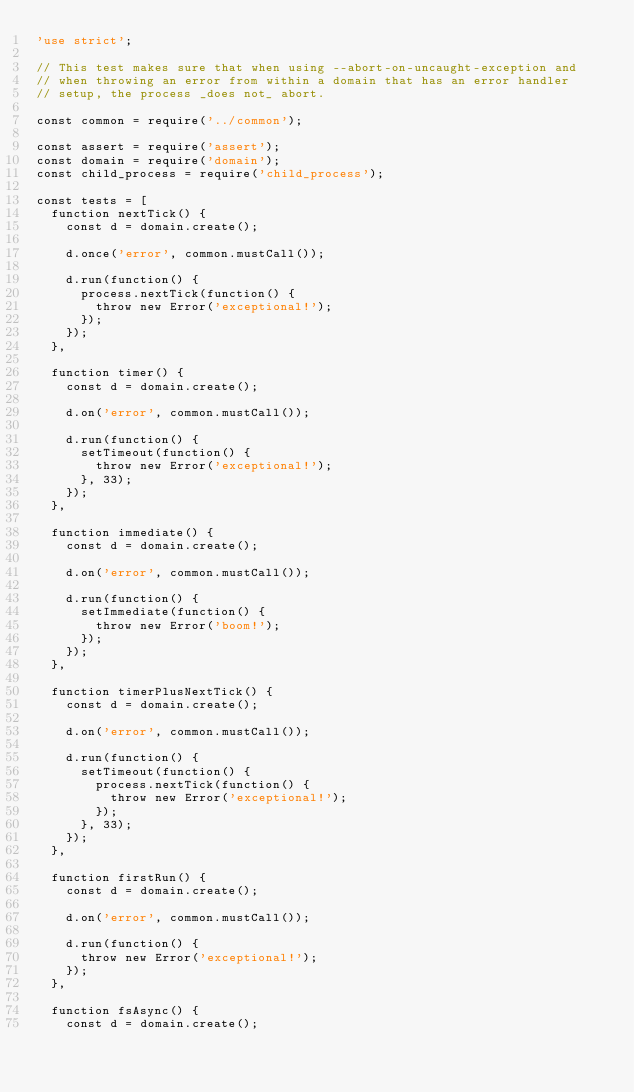Convert code to text. <code><loc_0><loc_0><loc_500><loc_500><_JavaScript_>'use strict';

// This test makes sure that when using --abort-on-uncaught-exception and
// when throwing an error from within a domain that has an error handler
// setup, the process _does not_ abort.

const common = require('../common');

const assert = require('assert');
const domain = require('domain');
const child_process = require('child_process');

const tests = [
  function nextTick() {
    const d = domain.create();

    d.once('error', common.mustCall());

    d.run(function() {
      process.nextTick(function() {
        throw new Error('exceptional!');
      });
    });
  },

  function timer() {
    const d = domain.create();

    d.on('error', common.mustCall());

    d.run(function() {
      setTimeout(function() {
        throw new Error('exceptional!');
      }, 33);
    });
  },

  function immediate() {
    const d = domain.create();

    d.on('error', common.mustCall());

    d.run(function() {
      setImmediate(function() {
        throw new Error('boom!');
      });
    });
  },

  function timerPlusNextTick() {
    const d = domain.create();

    d.on('error', common.mustCall());

    d.run(function() {
      setTimeout(function() {
        process.nextTick(function() {
          throw new Error('exceptional!');
        });
      }, 33);
    });
  },

  function firstRun() {
    const d = domain.create();

    d.on('error', common.mustCall());

    d.run(function() {
      throw new Error('exceptional!');
    });
  },

  function fsAsync() {
    const d = domain.create();
</code> 